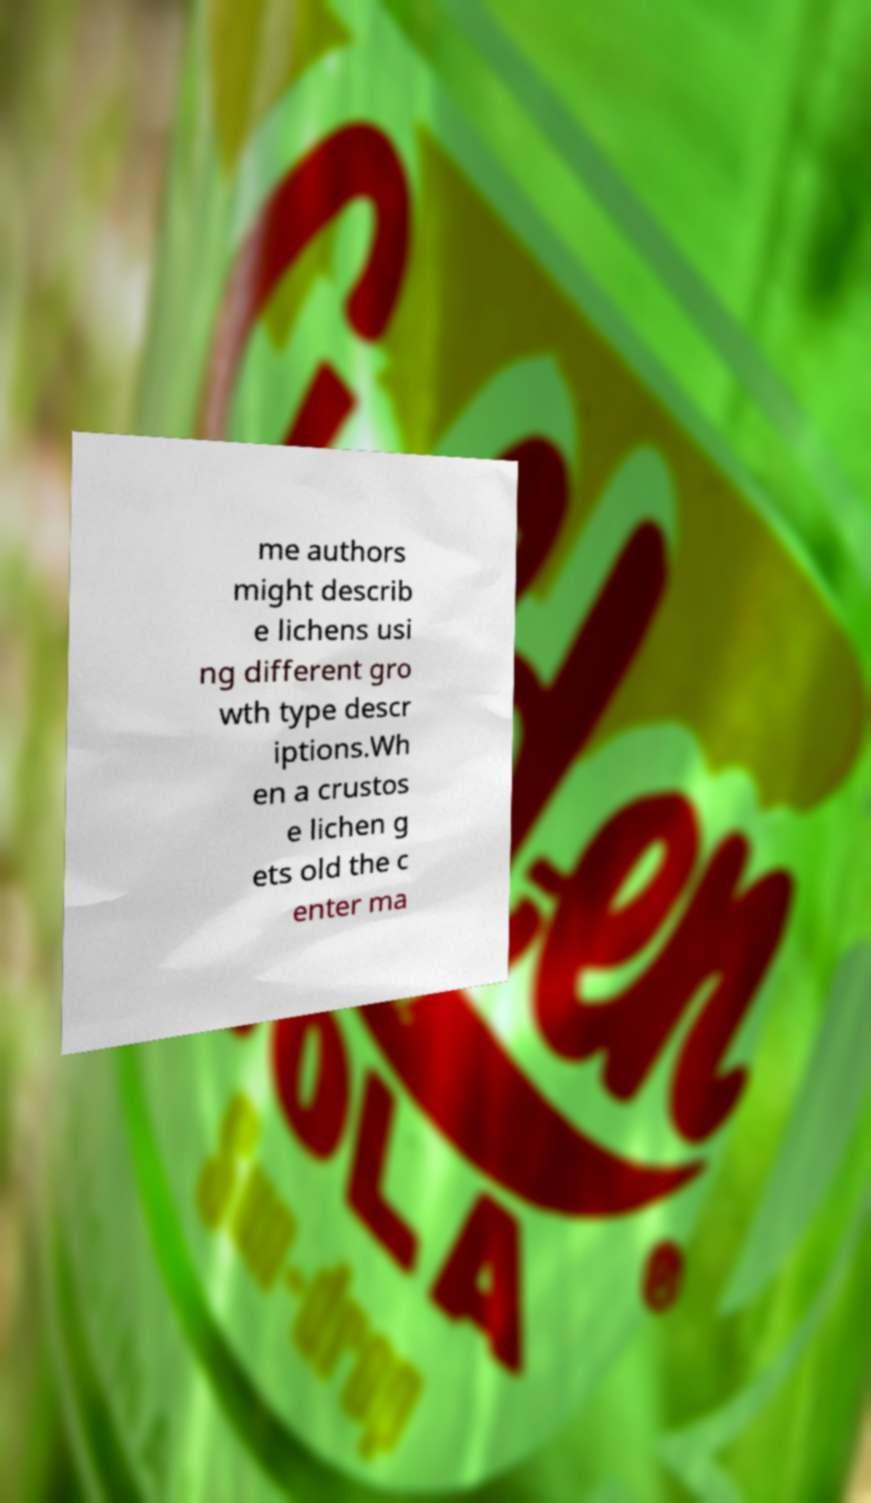Can you read and provide the text displayed in the image?This photo seems to have some interesting text. Can you extract and type it out for me? me authors might describ e lichens usi ng different gro wth type descr iptions.Wh en a crustos e lichen g ets old the c enter ma 